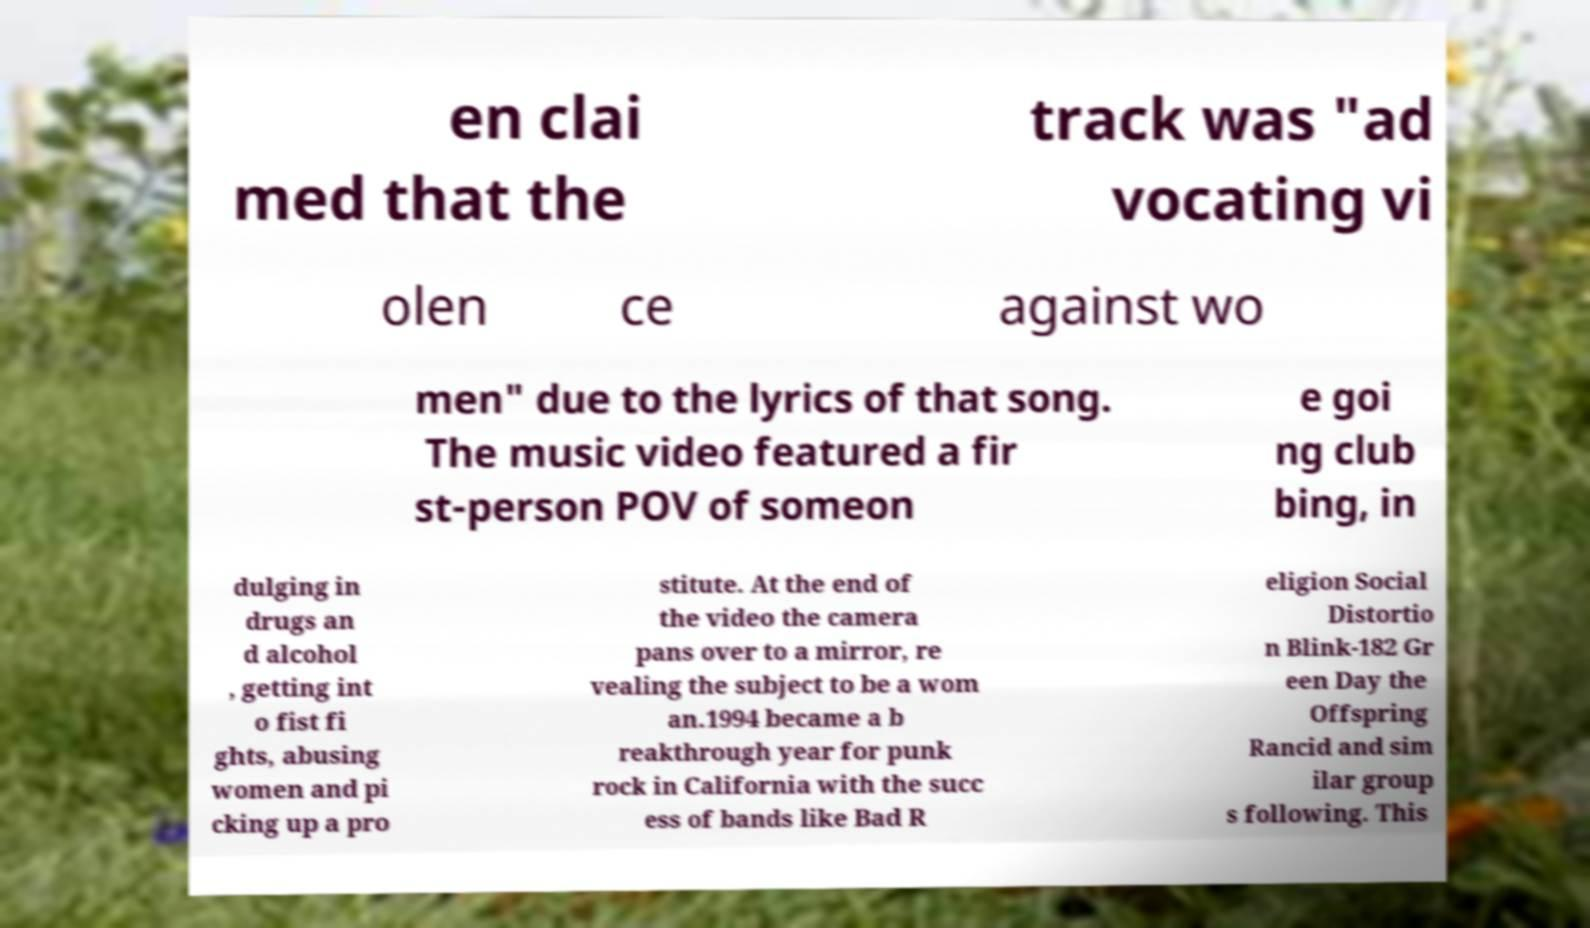Can you accurately transcribe the text from the provided image for me? en clai med that the track was "ad vocating vi olen ce against wo men" due to the lyrics of that song. The music video featured a fir st-person POV of someon e goi ng club bing, in dulging in drugs an d alcohol , getting int o fist fi ghts, abusing women and pi cking up a pro stitute. At the end of the video the camera pans over to a mirror, re vealing the subject to be a wom an.1994 became a b reakthrough year for punk rock in California with the succ ess of bands like Bad R eligion Social Distortio n Blink-182 Gr een Day the Offspring Rancid and sim ilar group s following. This 